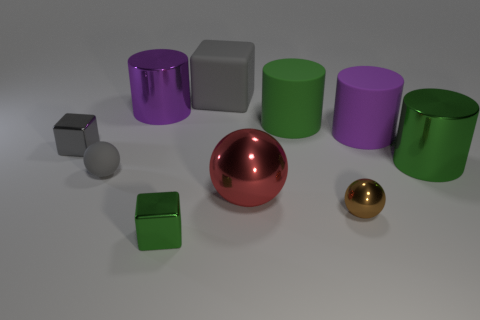Subtract all spheres. How many objects are left? 7 Subtract all red cubes. Subtract all red spheres. How many objects are left? 9 Add 4 tiny brown objects. How many tiny brown objects are left? 5 Add 8 green matte objects. How many green matte objects exist? 9 Subtract 1 brown spheres. How many objects are left? 9 